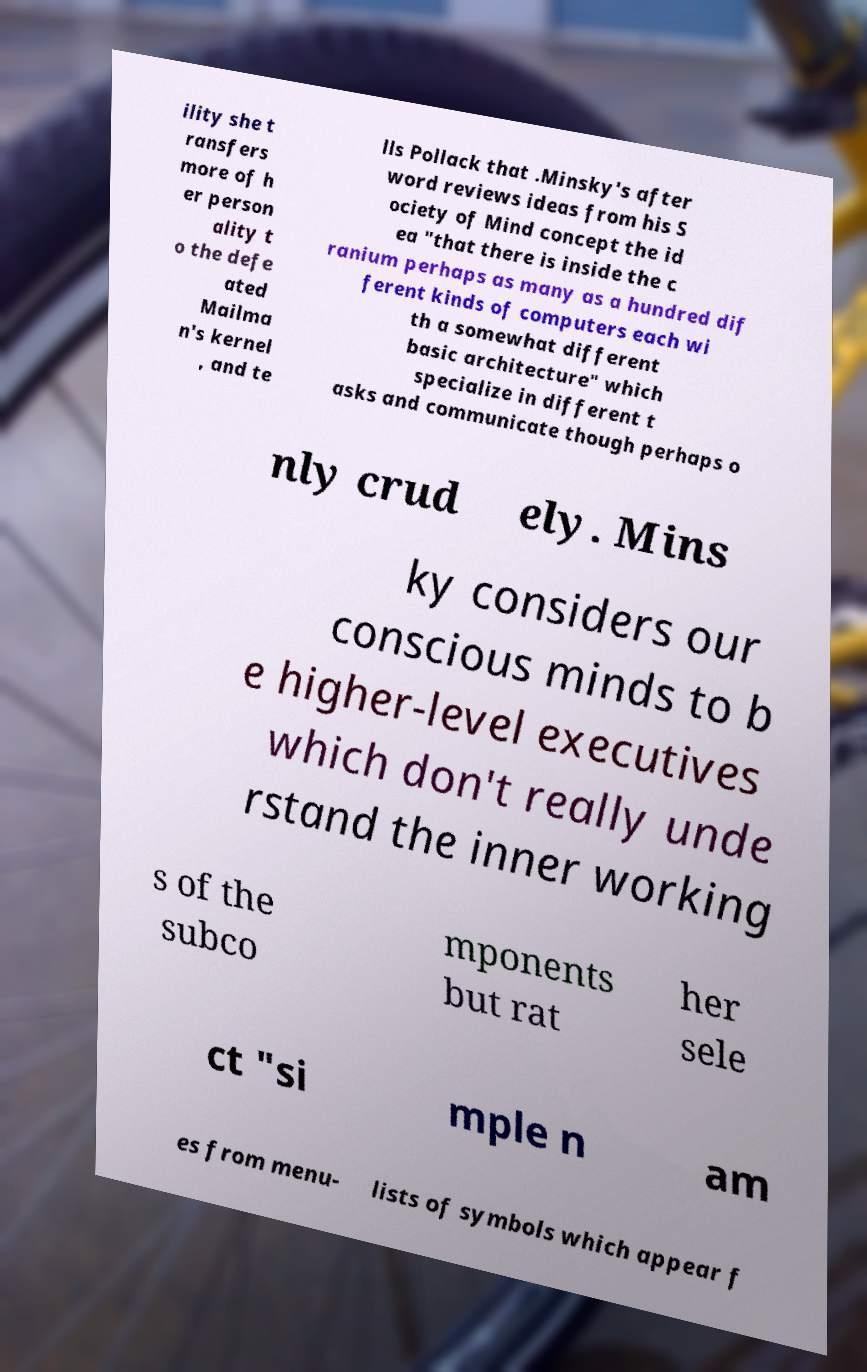Please read and relay the text visible in this image. What does it say? ility she t ransfers more of h er person ality t o the defe ated Mailma n's kernel , and te lls Pollack that .Minsky's after word reviews ideas from his S ociety of Mind concept the id ea "that there is inside the c ranium perhaps as many as a hundred dif ferent kinds of computers each wi th a somewhat different basic architecture" which specialize in different t asks and communicate though perhaps o nly crud ely. Mins ky considers our conscious minds to b e higher-level executives which don't really unde rstand the inner working s of the subco mponents but rat her sele ct "si mple n am es from menu- lists of symbols which appear f 